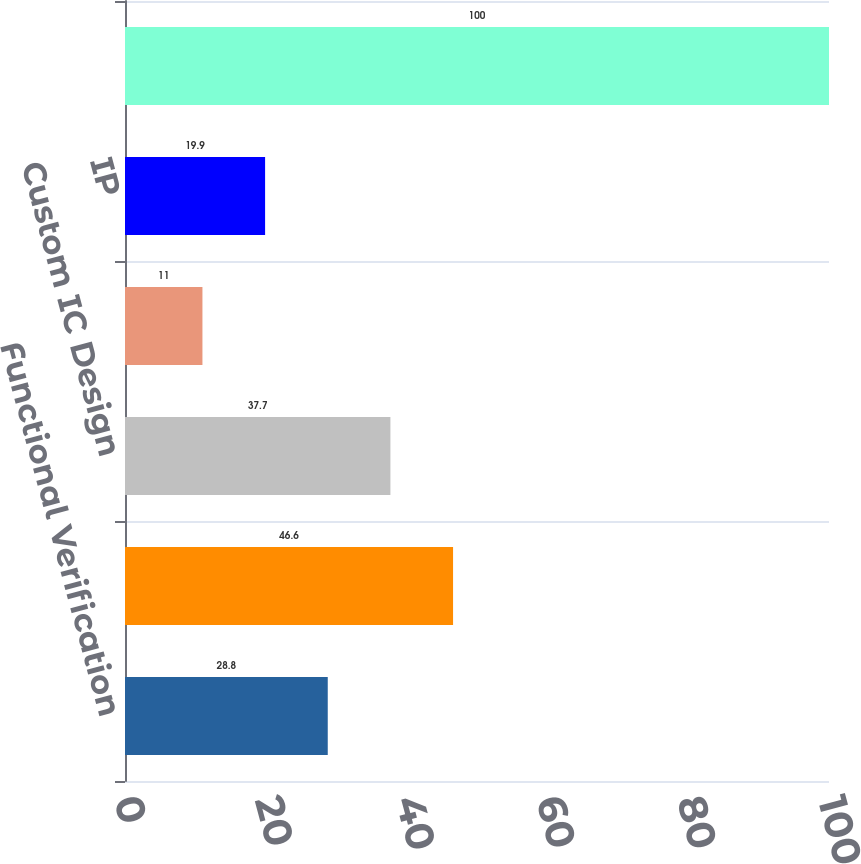Convert chart. <chart><loc_0><loc_0><loc_500><loc_500><bar_chart><fcel>Functional Verification<fcel>Digital IC Design and Signoff<fcel>Custom IC Design<fcel>System Interconnect and<fcel>IP<fcel>Total<nl><fcel>28.8<fcel>46.6<fcel>37.7<fcel>11<fcel>19.9<fcel>100<nl></chart> 